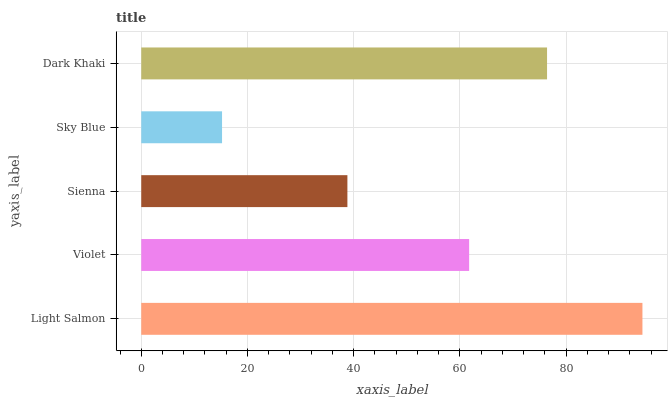Is Sky Blue the minimum?
Answer yes or no. Yes. Is Light Salmon the maximum?
Answer yes or no. Yes. Is Violet the minimum?
Answer yes or no. No. Is Violet the maximum?
Answer yes or no. No. Is Light Salmon greater than Violet?
Answer yes or no. Yes. Is Violet less than Light Salmon?
Answer yes or no. Yes. Is Violet greater than Light Salmon?
Answer yes or no. No. Is Light Salmon less than Violet?
Answer yes or no. No. Is Violet the high median?
Answer yes or no. Yes. Is Violet the low median?
Answer yes or no. Yes. Is Sky Blue the high median?
Answer yes or no. No. Is Sky Blue the low median?
Answer yes or no. No. 